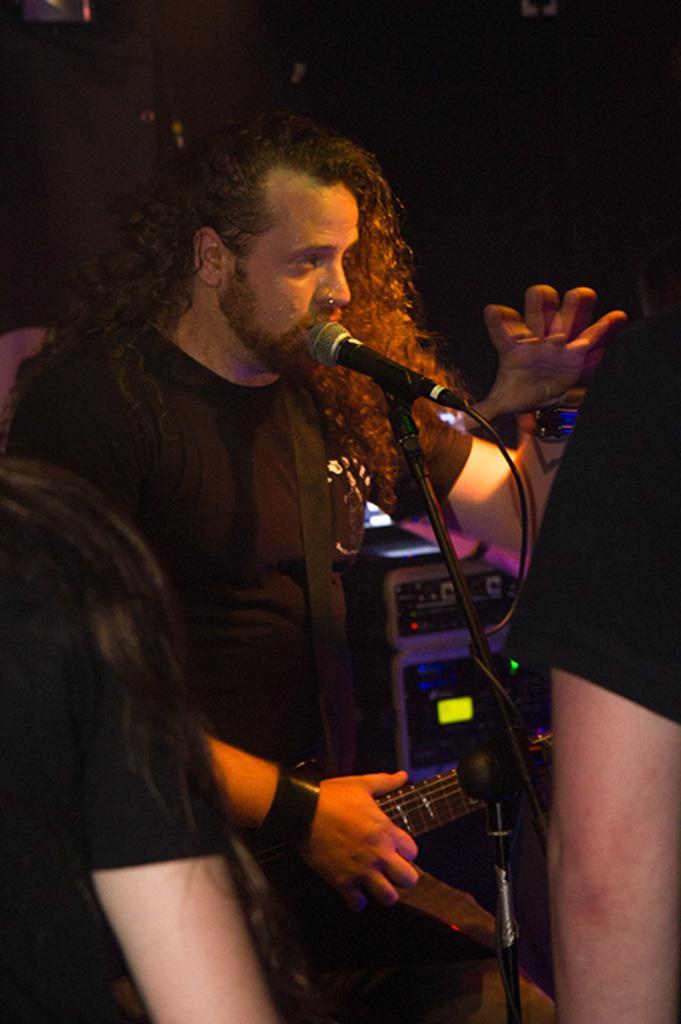How would you summarize this image in a sentence or two? This picture describes about group of people, in the middle of the image we can see a man, he is holding a guitar, in front of him we can see a microphone, in the background we can see few musical instruments. 